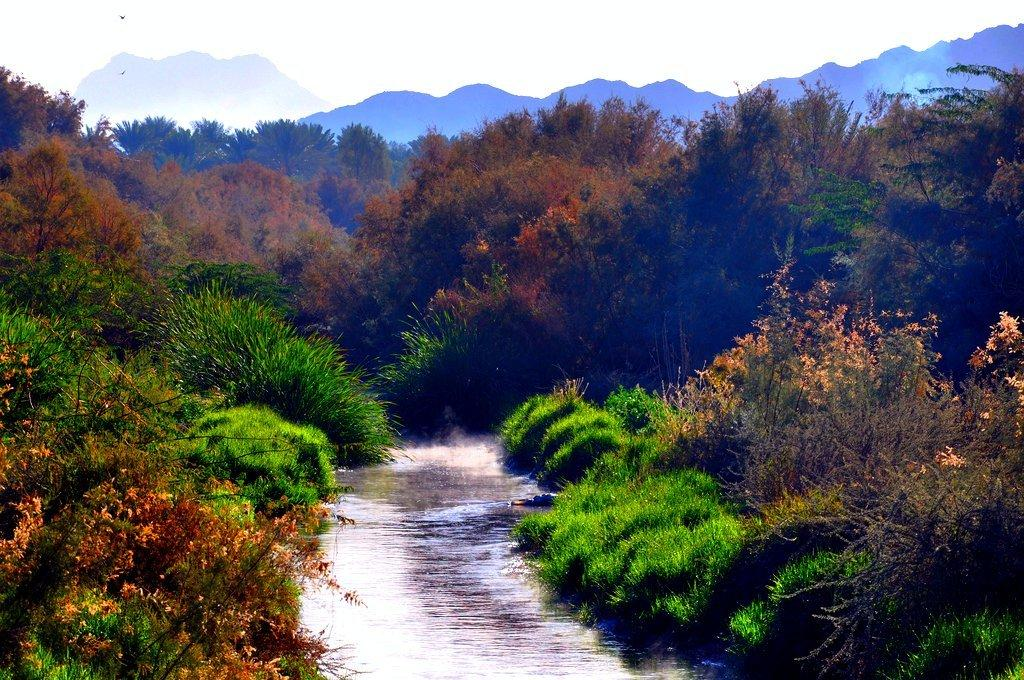What type of vegetation can be seen in the image? There are trees in the image. What is visible between the trees? There is water visible between the trees. What geographical feature is located at the top of the image? There is a mountain at the top of the image. What is visible at the very top of the image? The sky is visible at the top of the image. Can you smell the rose in the image? There is no rose present in the image, so it cannot be smelled. How does the mountain take a breath in the image? Mountains do not breathe, so this question is not applicable to the image. 